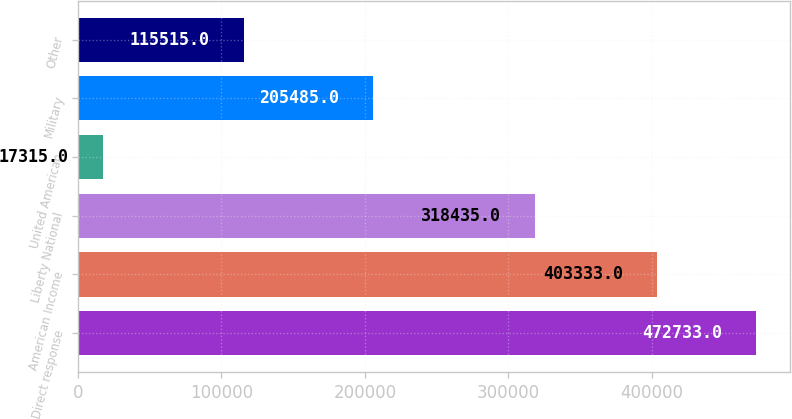<chart> <loc_0><loc_0><loc_500><loc_500><bar_chart><fcel>Direct response<fcel>American Income<fcel>Liberty National<fcel>United American<fcel>Military<fcel>Other<nl><fcel>472733<fcel>403333<fcel>318435<fcel>17315<fcel>205485<fcel>115515<nl></chart> 